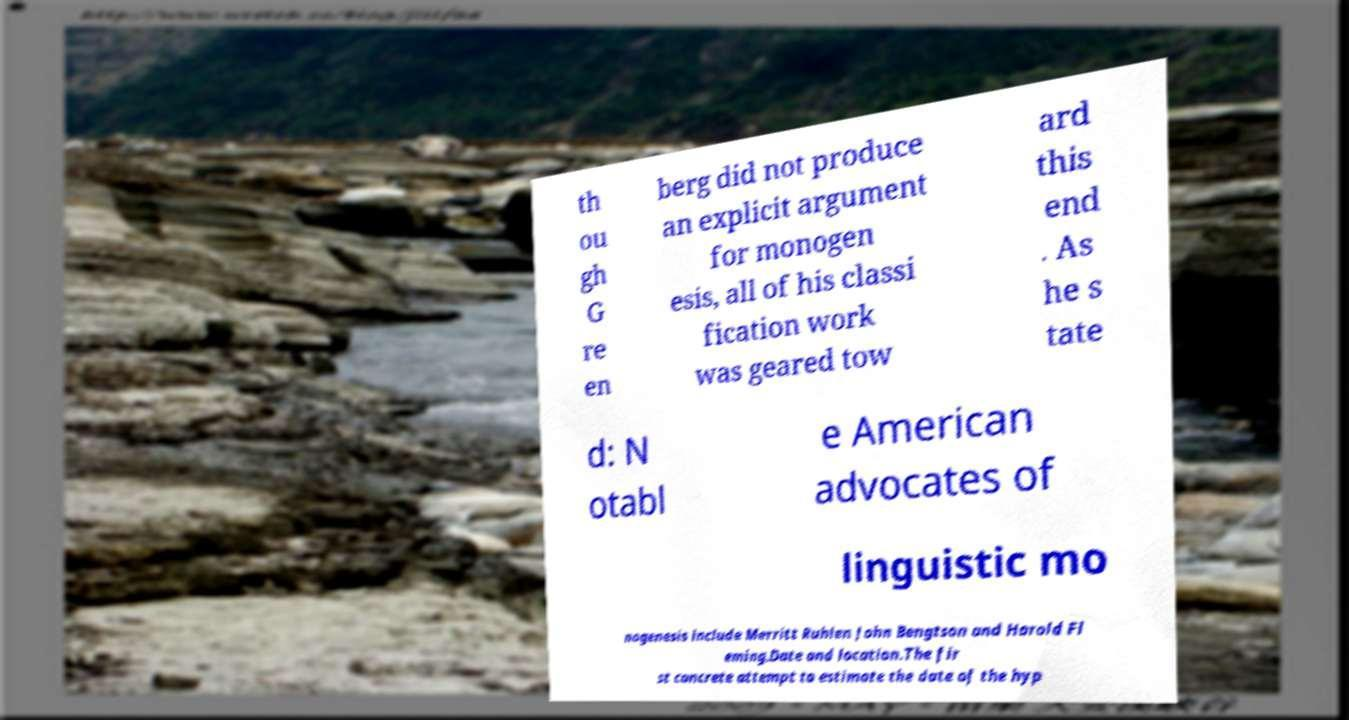Could you assist in decoding the text presented in this image and type it out clearly? th ou gh G re en berg did not produce an explicit argument for monogen esis, all of his classi fication work was geared tow ard this end . As he s tate d: N otabl e American advocates of linguistic mo nogenesis include Merritt Ruhlen John Bengtson and Harold Fl eming.Date and location.The fir st concrete attempt to estimate the date of the hyp 